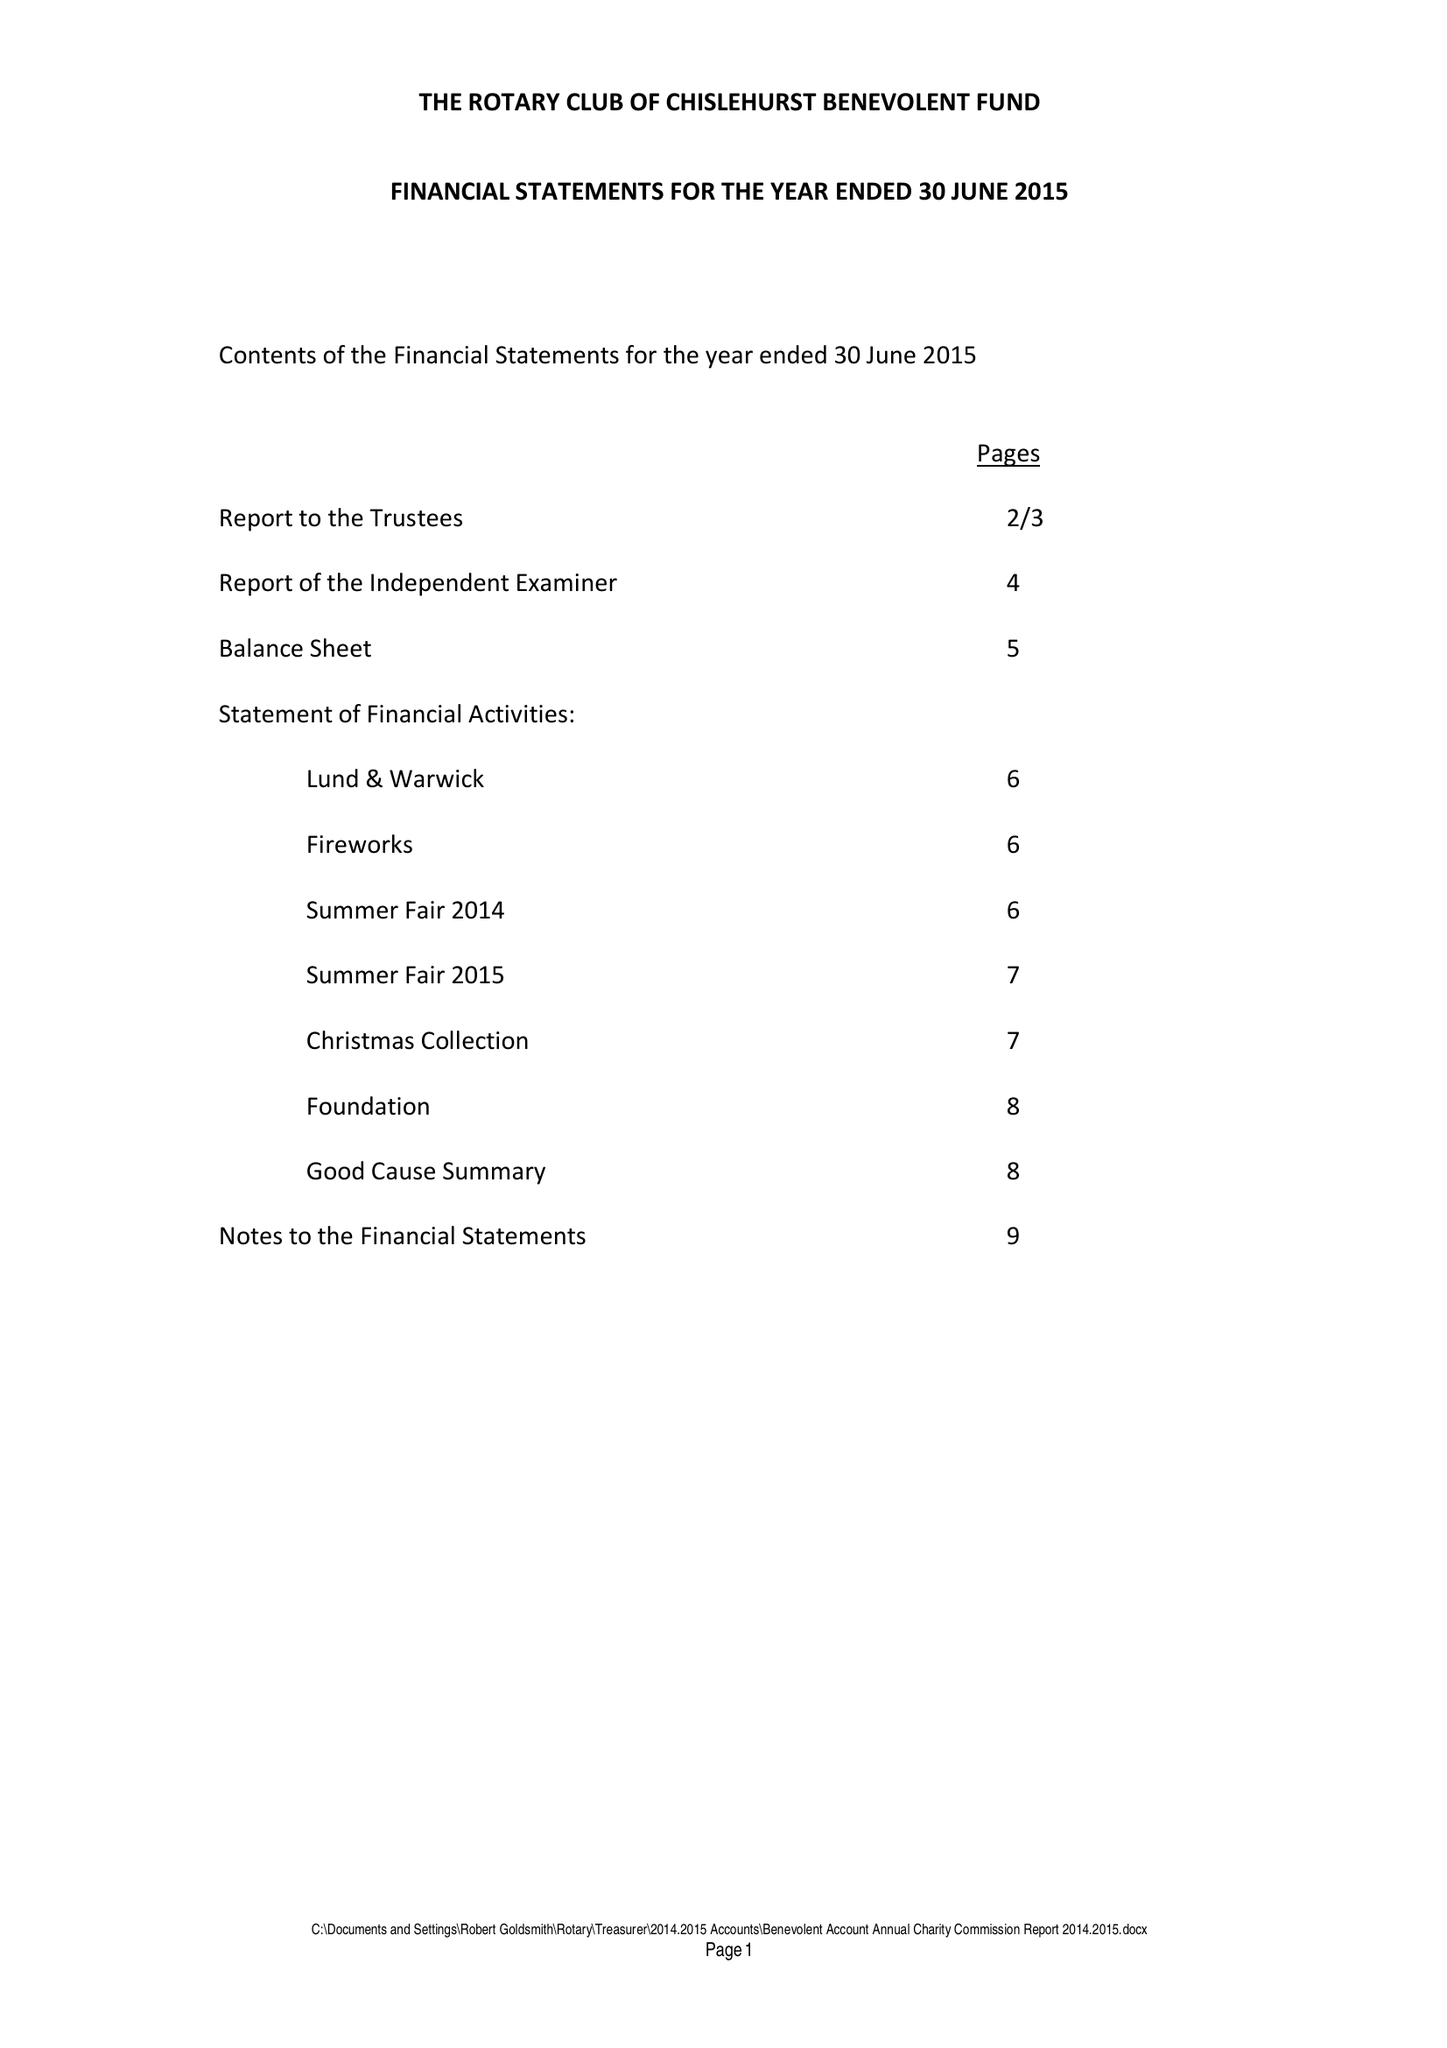What is the value for the address__post_town?
Answer the question using a single word or phrase. ORPINGTON 